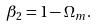<formula> <loc_0><loc_0><loc_500><loc_500>\beta _ { 2 } = 1 - \Omega _ { m } .</formula> 